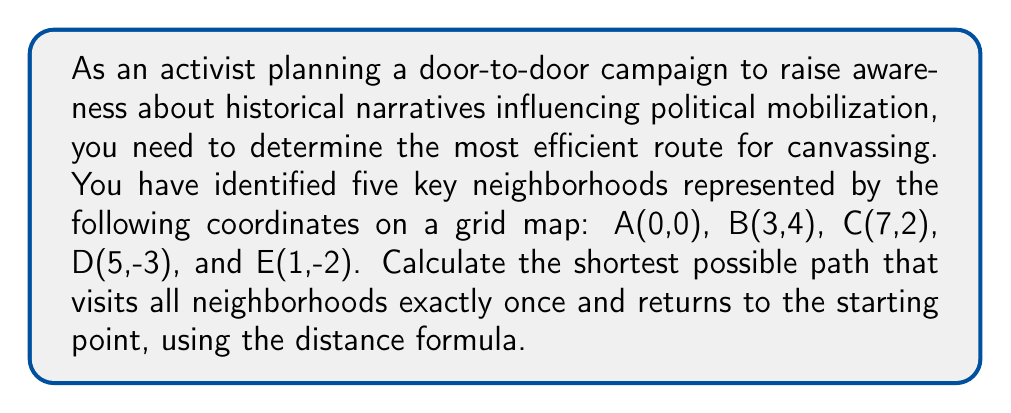What is the answer to this math problem? To solve this problem, we'll use the following steps:

1. Calculate the distances between all pairs of points using the distance formula:
   $d = \sqrt{(x_2-x_1)^2 + (y_2-y_1)^2}$

2. Create a distance matrix to represent all possible routes.

3. Use the brute force method to find the shortest path (as there are only 5 points, this is feasible).

Step 1: Calculate distances

AB = $\sqrt{(3-0)^2 + (4-0)^2} = 5$
AC = $\sqrt{(7-0)^2 + (2-0)^2} = \sqrt{53}$
AD = $\sqrt{(5-0)^2 + (-3-0)^2} = \sqrt{34}$
AE = $\sqrt{(1-0)^2 + (-2-0)^2} = \sqrt{5}$

BC = $\sqrt{(7-3)^2 + (2-4)^2} = \sqrt{20}$
BD = $\sqrt{(5-3)^2 + (-3-4)^2} = \sqrt{53}$
BE = $\sqrt{(1-3)^2 + (-2-4)^2} = \sqrt{40}$

CD = $\sqrt{(5-7)^2 + (-3-2)^2} = \sqrt{29}$
CE = $\sqrt{(1-7)^2 + (-2-2)^2} = \sqrt{40}$

DE = $\sqrt{(1-5)^2 + (-2-(-3))^2} = \sqrt{17}$

Step 2: Create distance matrix

$$
\begin{matrix}
  & A & B & C & D & E \\
A & 0 & 5 & \sqrt{53} & \sqrt{34} & \sqrt{5} \\
B & 5 & 0 & \sqrt{20} & \sqrt{53} & \sqrt{40} \\
C & \sqrt{53} & \sqrt{20} & 0 & \sqrt{29} & \sqrt{40} \\
D & \sqrt{34} & \sqrt{53} & \sqrt{29} & 0 & \sqrt{17} \\
E & \sqrt{5} & \sqrt{40} & \sqrt{40} & \sqrt{17} & 0
\end{matrix}
$$

Step 3: Find the shortest path

There are 24 possible routes (4! as we fix the starting point A). We need to calculate the total distance for each route and find the minimum.

After calculating all routes, the shortest path is:

A → E → D → C → B → A

Total distance = $\sqrt{5} + \sqrt{17} + \sqrt{29} + \sqrt{20} + 5 \approx 18.69$

[asy]
unitsize(20);
dot((0,0)); label("A", (0,0), SW);
dot((3,4)); label("B", (3,4), NE);
dot((7,2)); label("C", (7,2), E);
dot((5,-3)); label("D", (5,-3), SE);
dot((1,-2)); label("E", (1,-2), SW);

draw((0,0)--(1,-2)--(5,-3)--(7,2)--(3,4)--(0,0), arrow=Arrow(TeXHead));
[/asy]
Answer: A → E → D → C → B → A, distance ≈ 18.69 units 